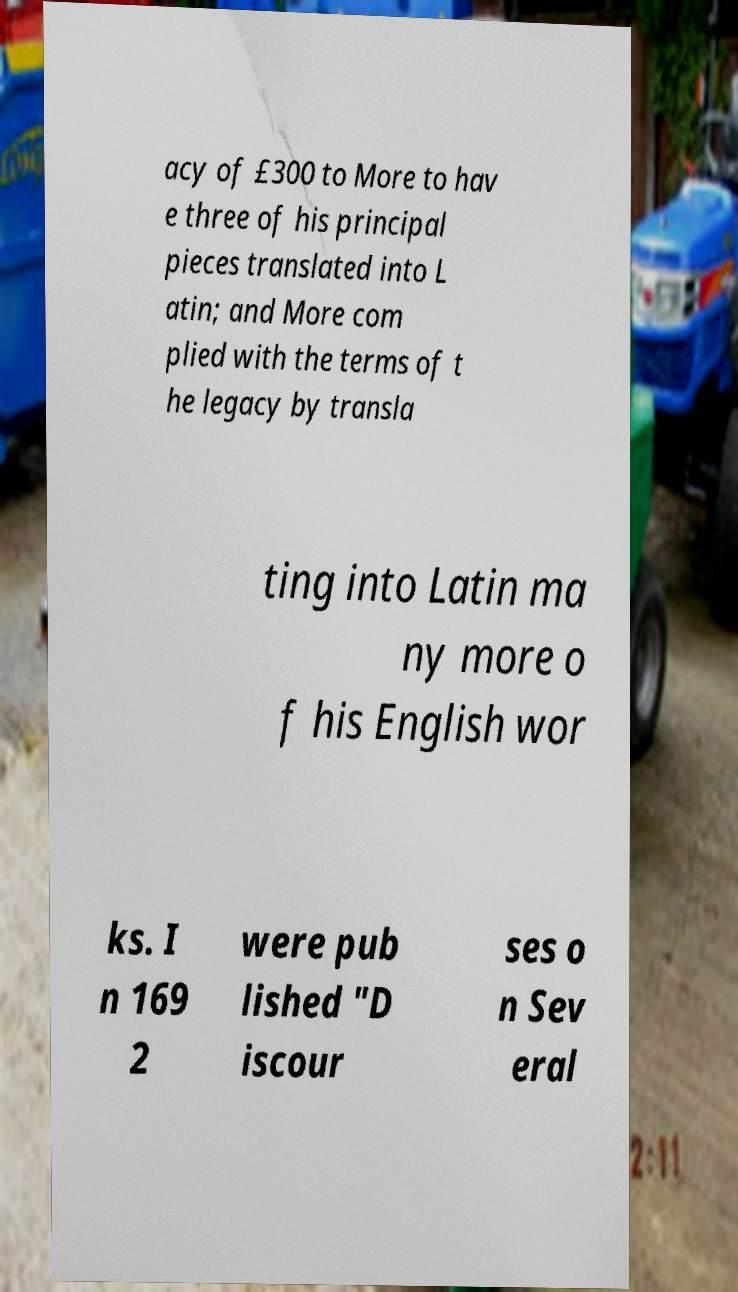For documentation purposes, I need the text within this image transcribed. Could you provide that? acy of £300 to More to hav e three of his principal pieces translated into L atin; and More com plied with the terms of t he legacy by transla ting into Latin ma ny more o f his English wor ks. I n 169 2 were pub lished "D iscour ses o n Sev eral 